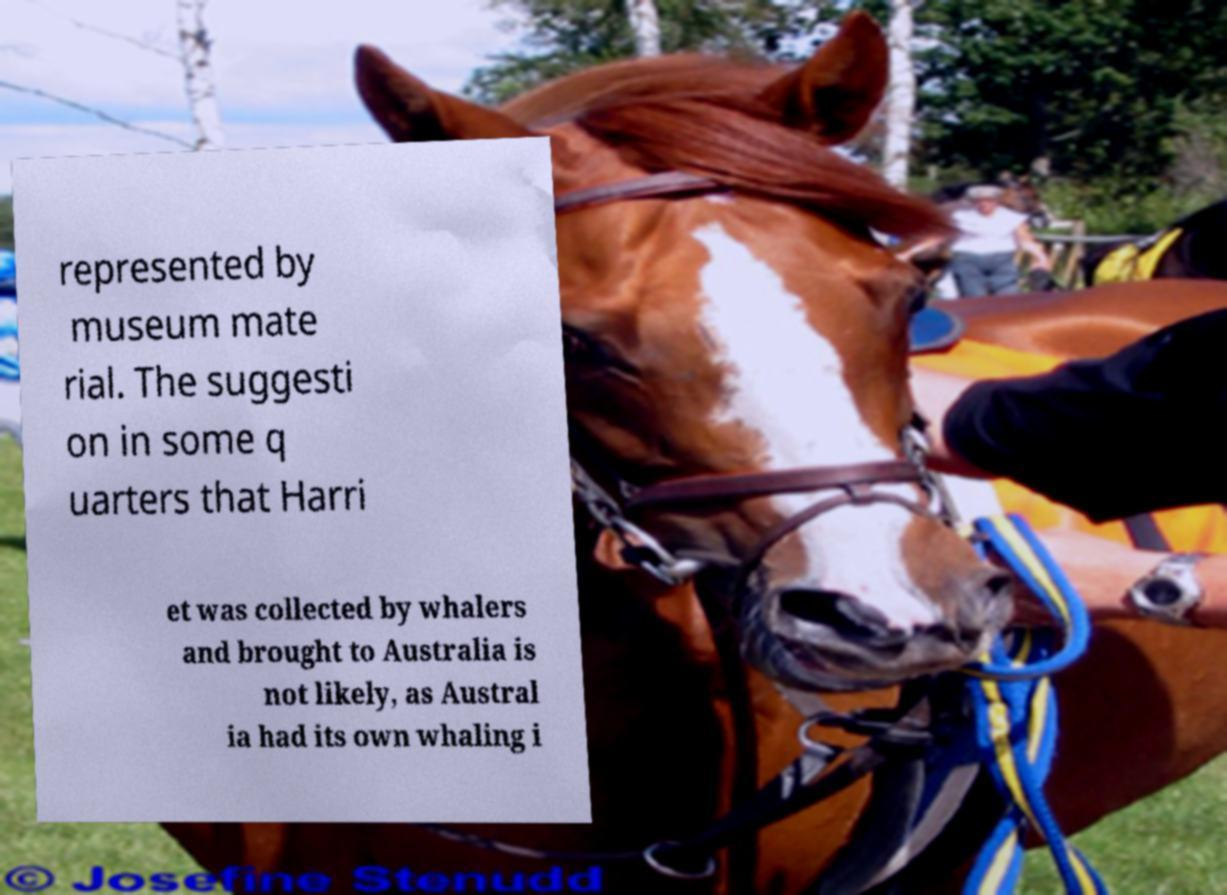I need the written content from this picture converted into text. Can you do that? represented by museum mate rial. The suggesti on in some q uarters that Harri et was collected by whalers and brought to Australia is not likely, as Austral ia had its own whaling i 